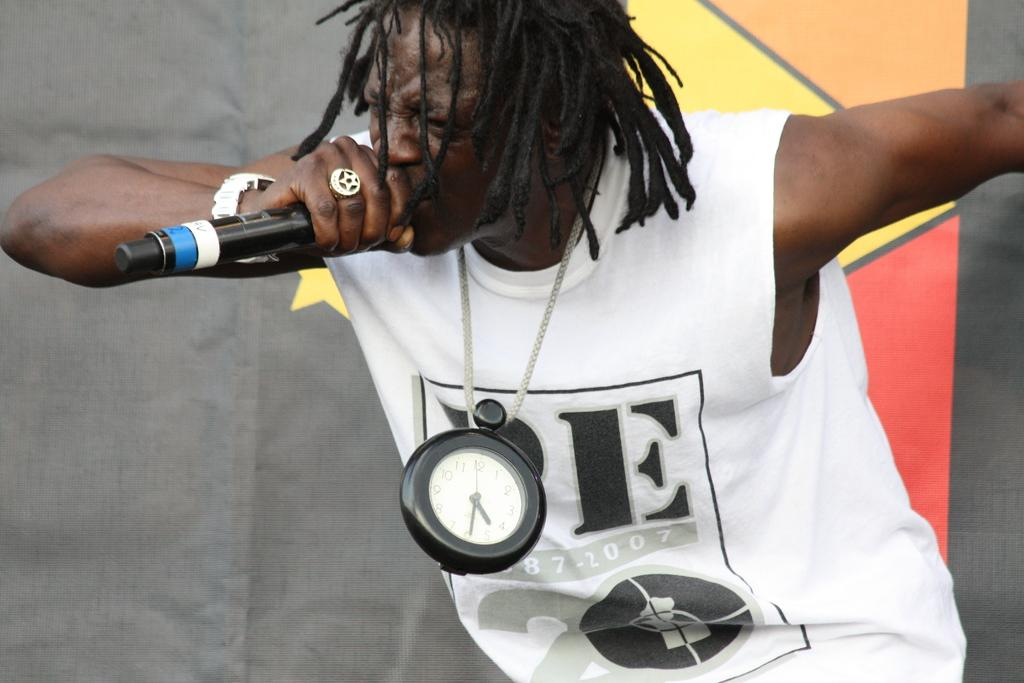<image>
Present a compact description of the photo's key features. A singer holding a mic and wearing a white t-shirt on which the letter E is visible and the year 2007. 